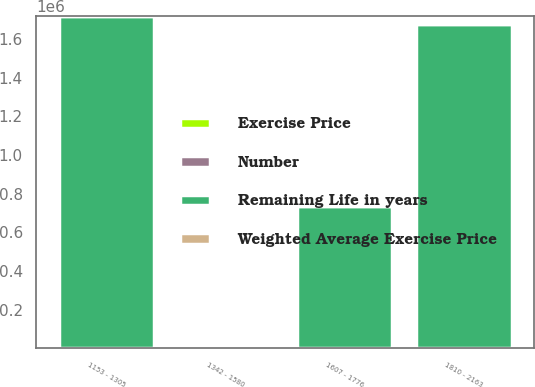Convert chart to OTSL. <chart><loc_0><loc_0><loc_500><loc_500><stacked_bar_chart><ecel><fcel>1153 - 1305<fcel>1342 - 1580<fcel>1607 - 1776<fcel>1810 - 2163<nl><fcel>Remaining Life in years<fcel>1.71753e+06<fcel>14.51<fcel>734089<fcel>1.6788e+06<nl><fcel>Weighted Average Exercise Price<fcel>5.7<fcel>7.6<fcel>1.8<fcel>0.8<nl><fcel>Number<fcel>12.85<fcel>14.51<fcel>16.85<fcel>18.45<nl><fcel>Exercise Price<fcel>12.85<fcel>14.42<fcel>16.85<fcel>18.45<nl></chart> 